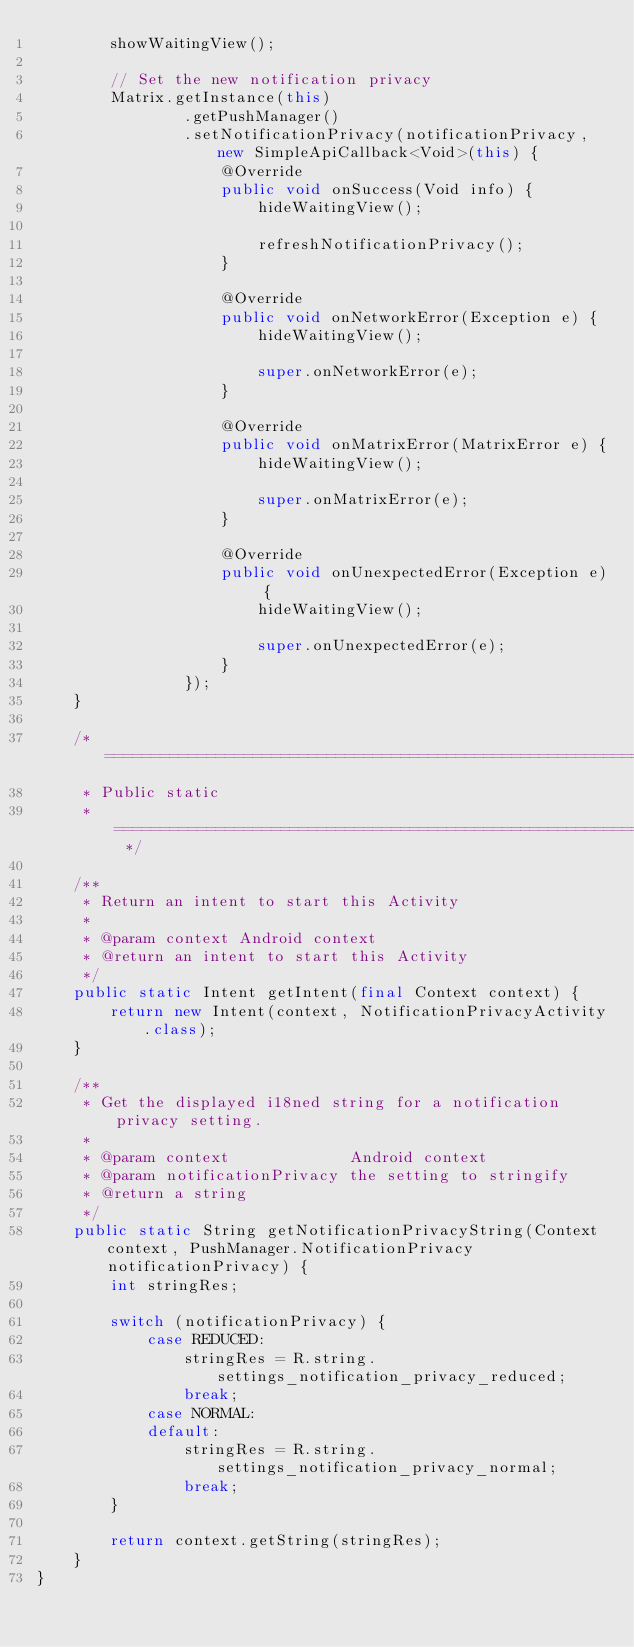<code> <loc_0><loc_0><loc_500><loc_500><_Java_>        showWaitingView();

        // Set the new notification privacy
        Matrix.getInstance(this)
                .getPushManager()
                .setNotificationPrivacy(notificationPrivacy, new SimpleApiCallback<Void>(this) {
                    @Override
                    public void onSuccess(Void info) {
                        hideWaitingView();

                        refreshNotificationPrivacy();
                    }

                    @Override
                    public void onNetworkError(Exception e) {
                        hideWaitingView();

                        super.onNetworkError(e);
                    }

                    @Override
                    public void onMatrixError(MatrixError e) {
                        hideWaitingView();

                        super.onMatrixError(e);
                    }

                    @Override
                    public void onUnexpectedError(Exception e) {
                        hideWaitingView();

                        super.onUnexpectedError(e);
                    }
                });
    }

    /* ==========================================================================================
     * Public static
     * ========================================================================================== */

    /**
     * Return an intent to start this Activity
     *
     * @param context Android context
     * @return an intent to start this Activity
     */
    public static Intent getIntent(final Context context) {
        return new Intent(context, NotificationPrivacyActivity.class);
    }

    /**
     * Get the displayed i18ned string for a notification privacy setting.
     *
     * @param context             Android context
     * @param notificationPrivacy the setting to stringify
     * @return a string
     */
    public static String getNotificationPrivacyString(Context context, PushManager.NotificationPrivacy notificationPrivacy) {
        int stringRes;

        switch (notificationPrivacy) {
            case REDUCED:
                stringRes = R.string.settings_notification_privacy_reduced;
                break;
            case NORMAL:
            default:
                stringRes = R.string.settings_notification_privacy_normal;
                break;
        }

        return context.getString(stringRes);
    }
}
</code> 